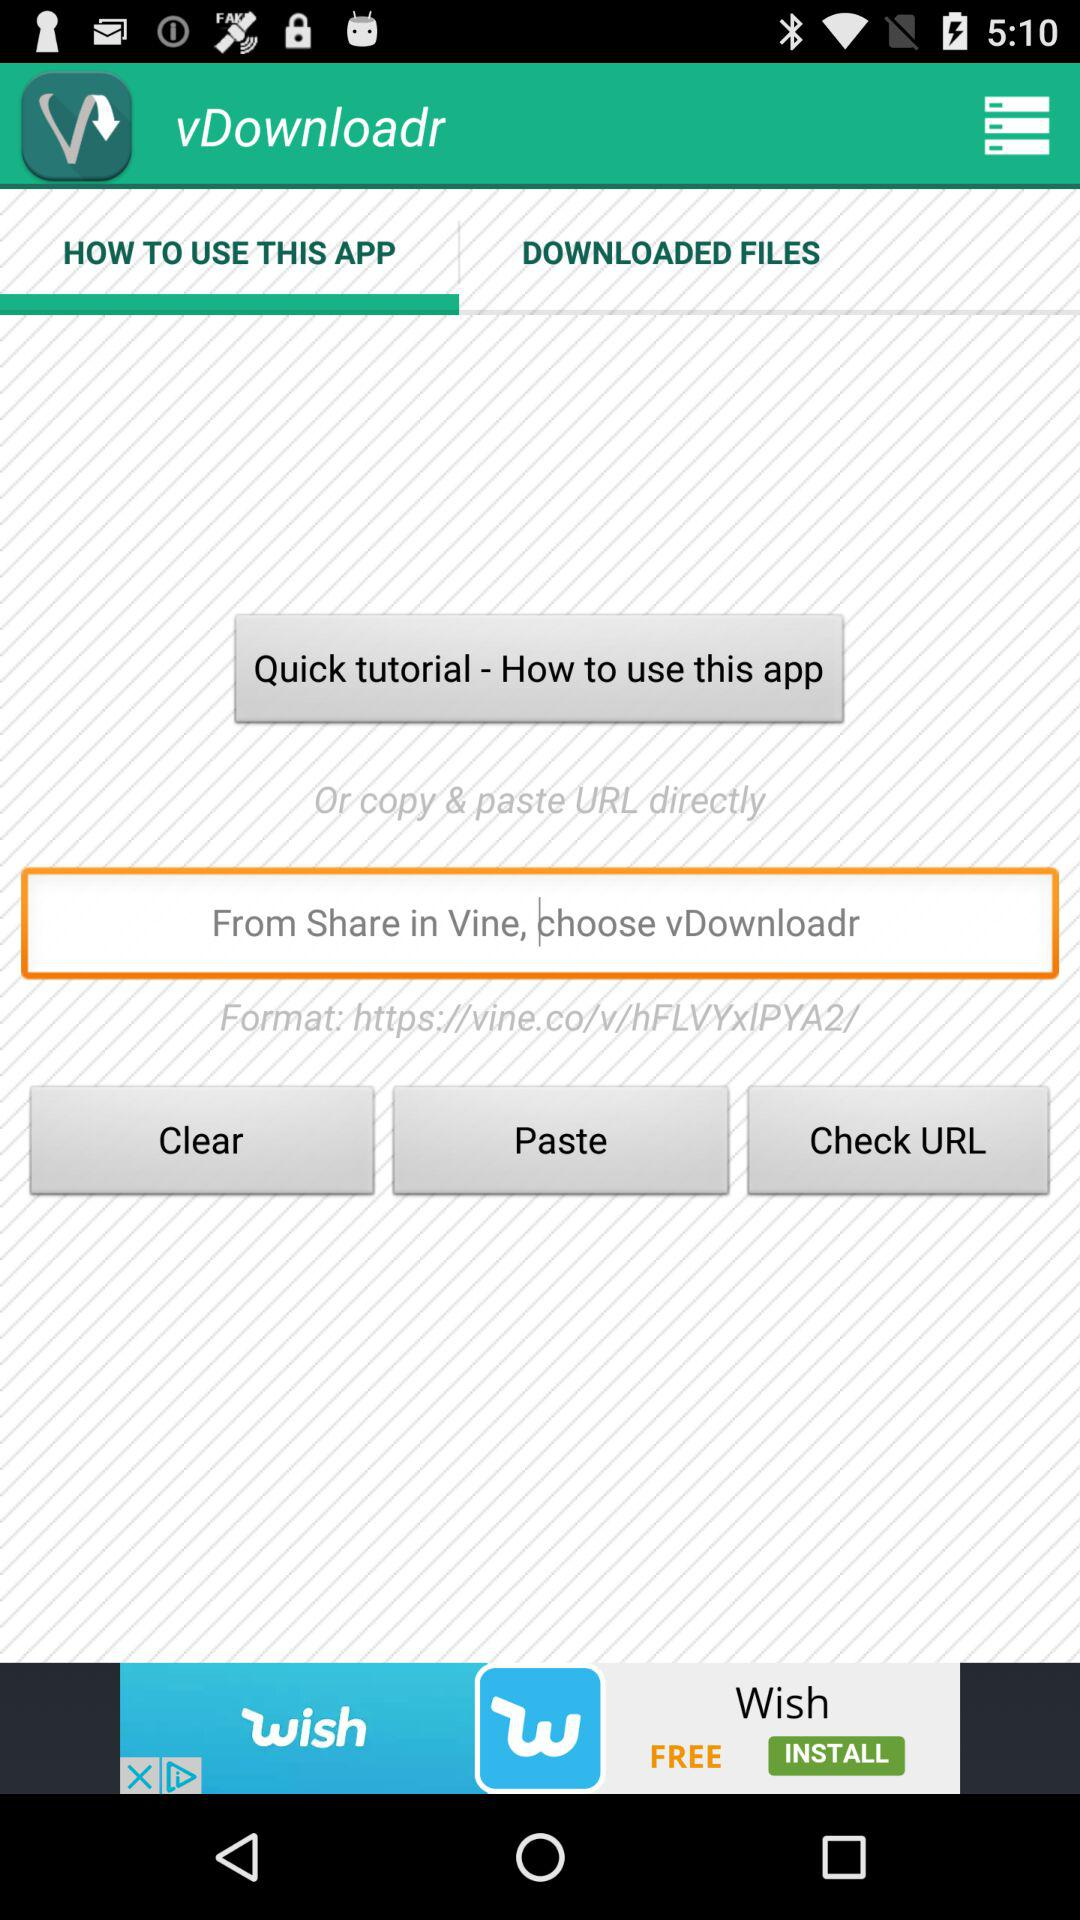What is the URL? The URL is https://vine.co/v/hFLVYxIPYA2/. 